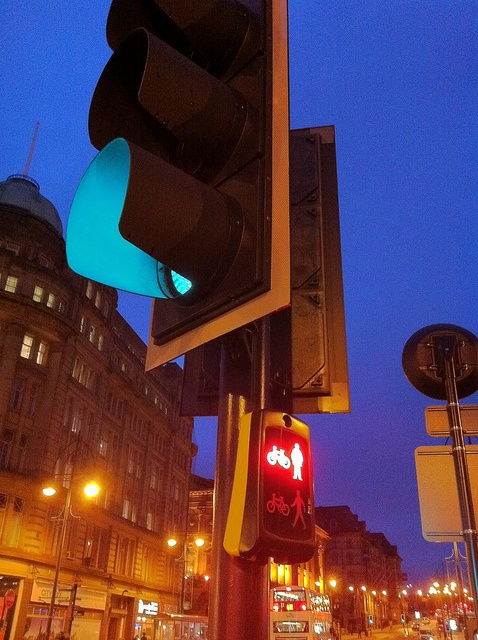Describe the objects in this image and their specific colors. I can see traffic light in blue, black, lightblue, brown, and maroon tones, traffic light in blue, black, maroon, and brown tones, traffic light in blue, maroon, brown, orange, and red tones, car in blue, brown, maroon, tan, and salmon tones, and car in blue, brown, salmon, and tan tones in this image. 